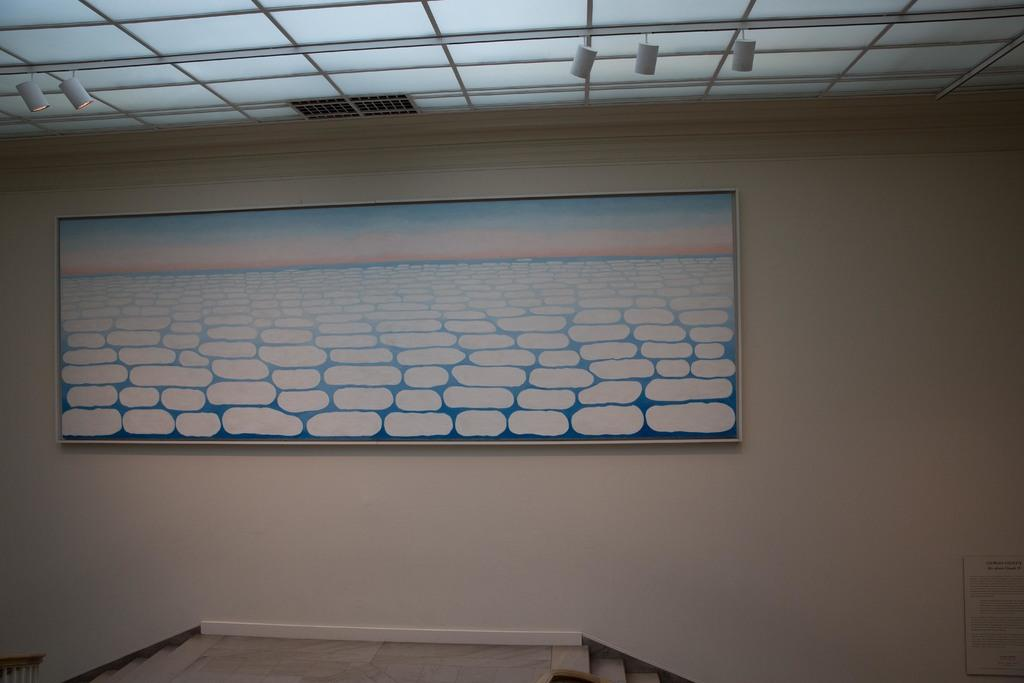What is located in the middle of the image? There is a wall in the middle of the image. What is attached to the wall? There is a painting frame on the wall. What can be seen above the wall in the image? There is a ceiling with lights in the image. What architectural feature is visible at the bottom of the image? There is a staircase at the bottom of the image. What type of brass instrument is being played in the image? There is no brass instrument or any indication of music being played in the image. 